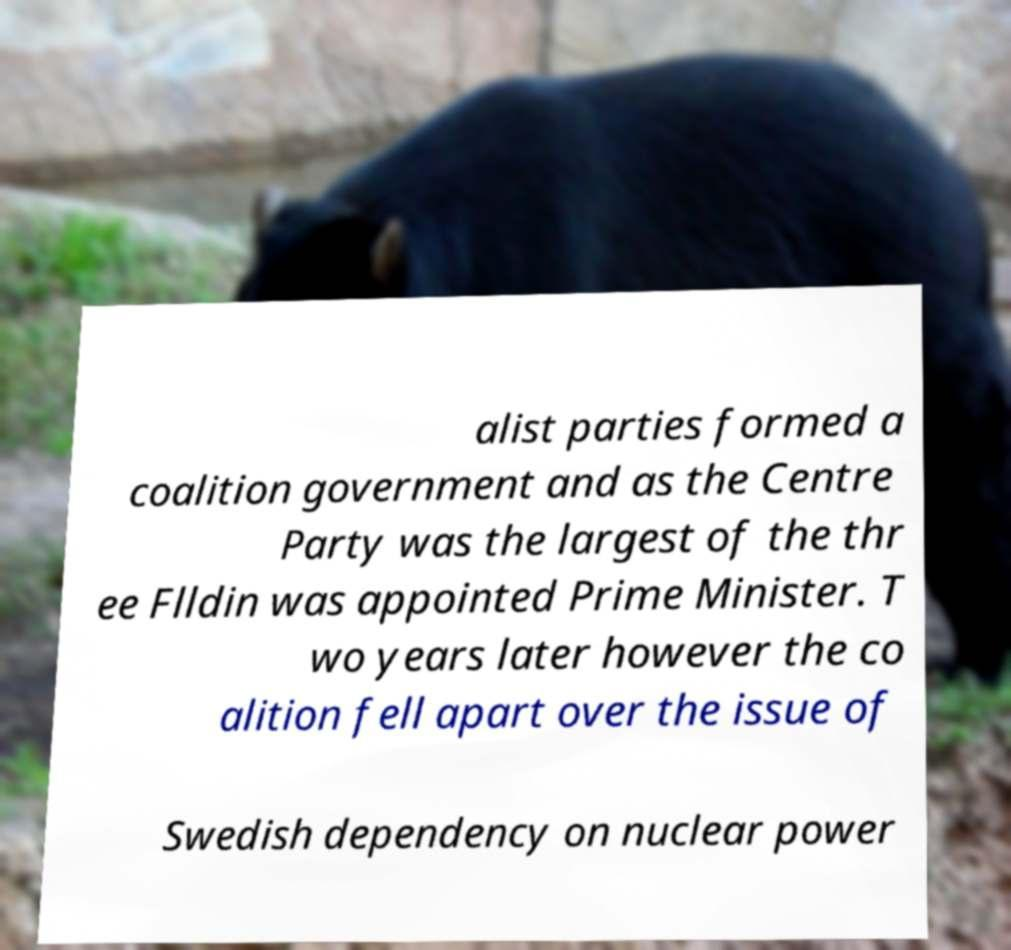For documentation purposes, I need the text within this image transcribed. Could you provide that? alist parties formed a coalition government and as the Centre Party was the largest of the thr ee Flldin was appointed Prime Minister. T wo years later however the co alition fell apart over the issue of Swedish dependency on nuclear power 